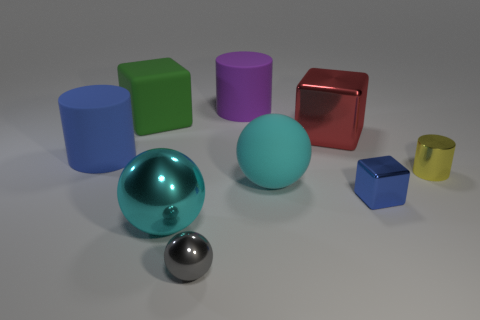Subtract all big rubber cylinders. How many cylinders are left? 1 Subtract all cylinders. How many objects are left? 6 Subtract all green matte things. Subtract all red metallic cubes. How many objects are left? 7 Add 5 red blocks. How many red blocks are left? 6 Add 6 big red matte balls. How many big red matte balls exist? 6 Subtract 1 purple cylinders. How many objects are left? 8 